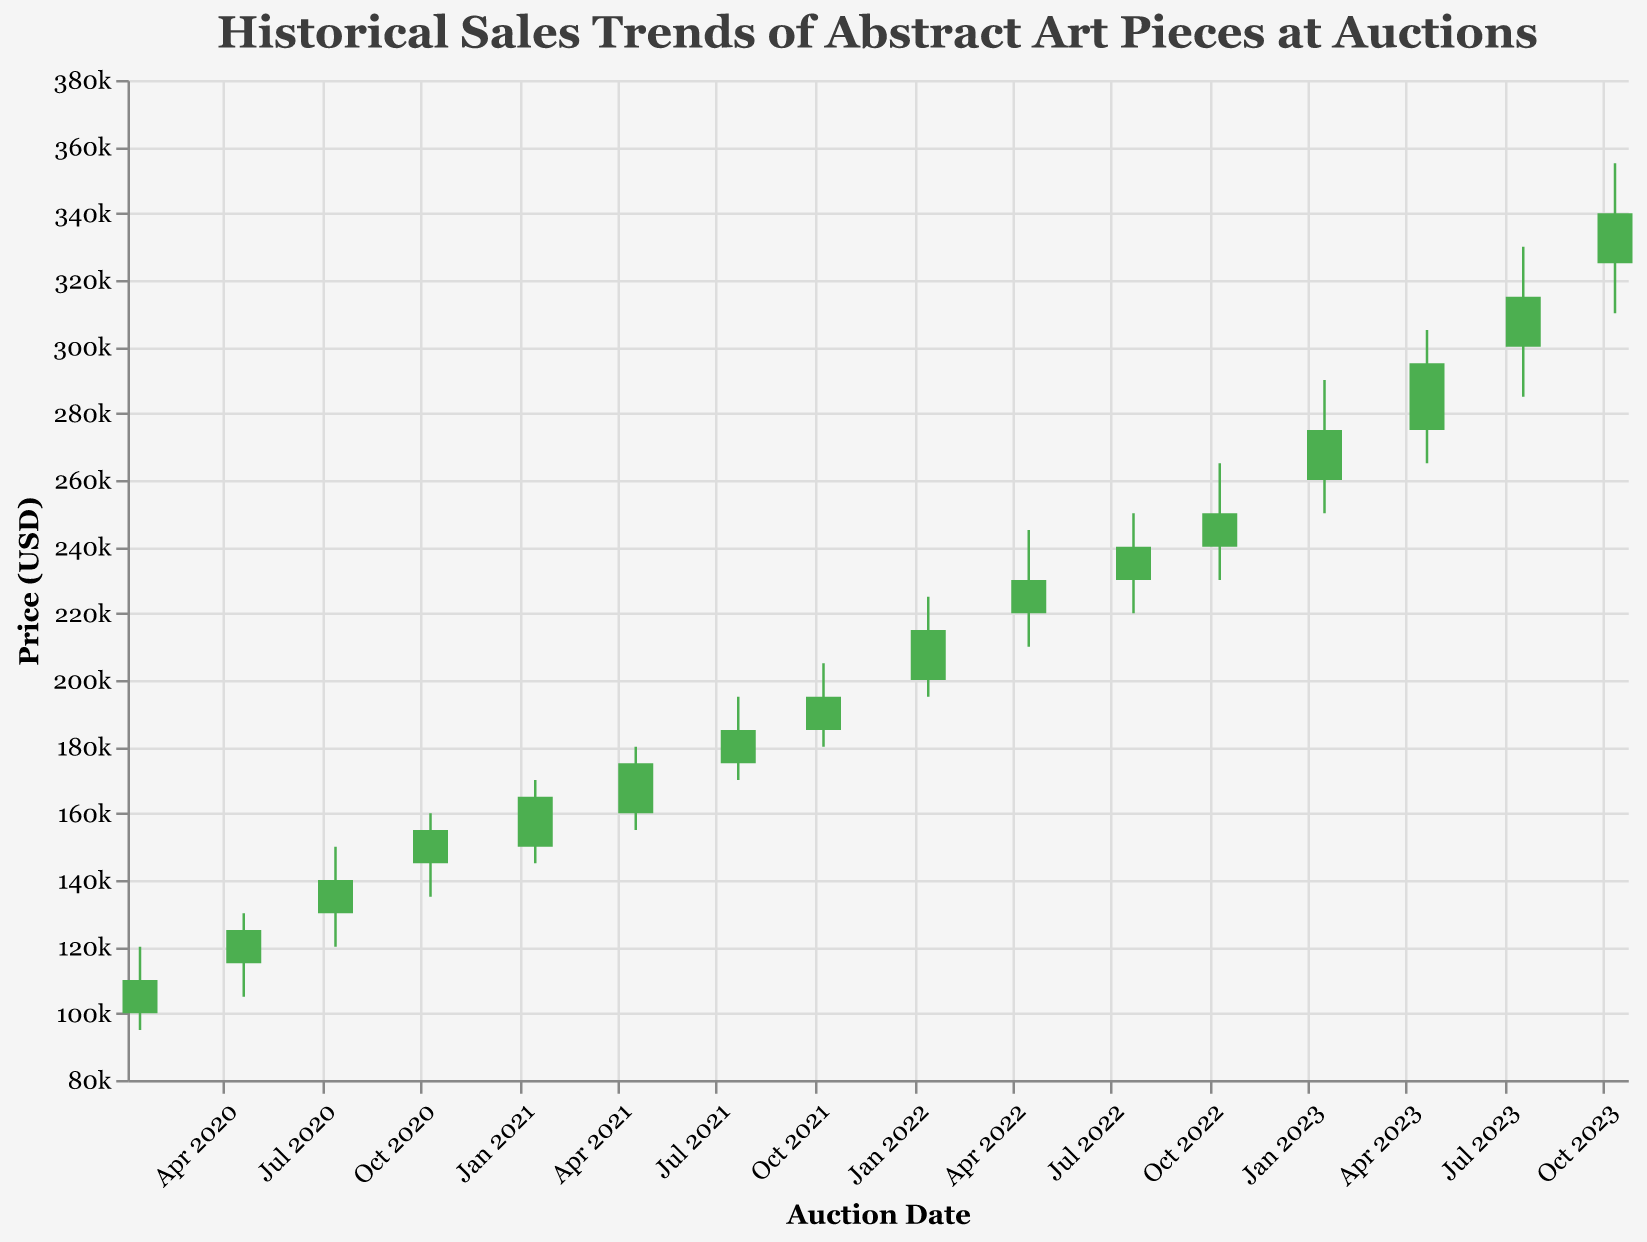What is the title of the figure? The title is typically located at the top of the plot and provides a brief description of what the plot represents. Here it reads "Historical Sales Trends of Abstract Art Pieces at Auctions."
Answer: Historical Sales Trends of Abstract Art Pieces at Auctions What does the x-axis represent? The x-axis labels typically describe what the data points on the horizontal axis represent. Here, the x-axis is labeled "Auction Date" with dates formatted as "Date Month Year".
Answer: Auction Date What are the colors used to indicate different trends in the plot? The colors in the plot are crucial for easily interpreting the data. Looking at the plot, green (#4CAF50) indicates that the closing price was higher than the opening price, while red (#FF5252) indicates the opposite.
Answer: Green and Red Between which dates does the data in the plot range? The range of dates on the x-axis will give this information. The first data point is from "2020-01-15" and the last one is "2023-10-12".
Answer: January 2020 to October 2023 What is the price range displayed on the y-axis? The y-axis shows the price scale for the auction data points. Here, the scale ranges from 80,000 to 380,000 USD as indicated by the labels.
Answer: 80,000 to 380,000 USD What was the closing price on 2022-04-17? Referring to the data for the date, find the "Close" value for "2022-04-17", which is 230,000.
Answer: 230,000 USD What was the highest price recorded in the entire dataset? Locate the highest value on the "High" column in the dataset, which corresponds to the point on "2023-07-19" where the high value is 330,000.
Answer: 355,000 USD Which auction saw the largest difference between the high and low prices? Calculate the range (High - Low) for each date and identify the date with the largest difference. The values are:
- 2020-01-15: 120,000 - 95,000 = 25,000
- 2020-04-20: 130,000 - 105,000 = 25,000
- 2020-07-14: 150,000 - 120,000 = 30,000
- 2020-10-10: 160,000 - 135,000 = 25,000
- 2021-01-15: 170,000 - 145,000 = 25,000
- 2021-04-18: 180,000 - 155,000 = 25,000
- 2021-07-22: 195,000 - 170,000 = 25,000
- 2021-10-09: 205,000 - 180,000 = 25,000
- 2022-01-14: 225,000 - 195,000 = 30,000
- 2022-04-17: 245,000 - 210,000 = 35,000
- 2022-07-23: 250,000 - 220,000 = 30,000
- 2022-10-11: 265,000 - 230,000 = 35,000
- 2023-01-16: 290,000 - 250,000 = 40,000
- 2023-04-21: 305,000 - 265,000 = 40,000
- 2023-07-19: 330,000 - 285,000 = 45,000
- 2023-10-12: 355,000 - 310,000 = 45,000
The largest difference, 45,000, occurs on 2023-07-19 and 2023-10-12.
Answer: 2023-07-19 and 2023-10-12 Which quarter consistently shows the highest closing prices from 2020 to 2023? Analyzing the closing prices for each quarter:
- Q1: 110,000 (2020-01-15), 165,000 (2021-01-15), 215,000 (2022-01-14), 275,000 (2023-01-16)
- Q2: 125,000 (2020-04-20), 175,000 (2021-04-18), 230,000 (2022-04-17), 295,000 (2023-04-21)
- Q3: 140,000 (2020-07-14), 185,000 (2021-07-22), 240,000 (2022-07-23), 315,000 (2023-07-19)
- Q4: 155,000 (2020-10-10), 195,000 (2021-10-09), 250,000 (2022-10-11), 340,000 (2023-10-12)
Q4 consistently shows the highest closing prices each year.
Answer: Q4 Was there any auction where the opening and closing prices were the same? Fetch all closing prices and compare them to their corresponding opening prices:
- Observe that none of the opening prices equal their corresponding closing prices.
Answer: No 